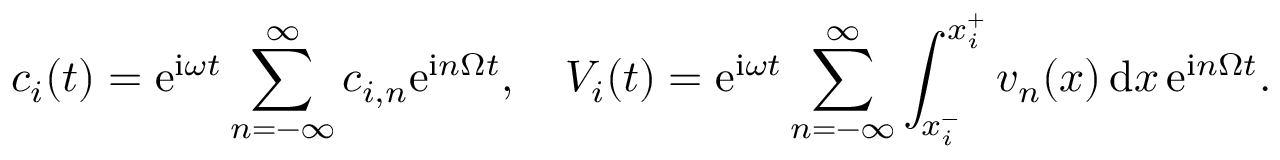<formula> <loc_0><loc_0><loc_500><loc_500>c _ { i } ( t ) = e ^ { i \omega t } \sum _ { n = - \infty } ^ { \infty } c _ { i , n } e ^ { i n \Omega t } , \quad V _ { i } ( t ) = e ^ { i \omega t } \sum _ { n = - \infty } ^ { \infty } \int _ { x _ { i } ^ { - } } ^ { x _ { i } ^ { + } } v _ { n } ( x ) \, d x \, e ^ { i n \Omega t } .</formula> 